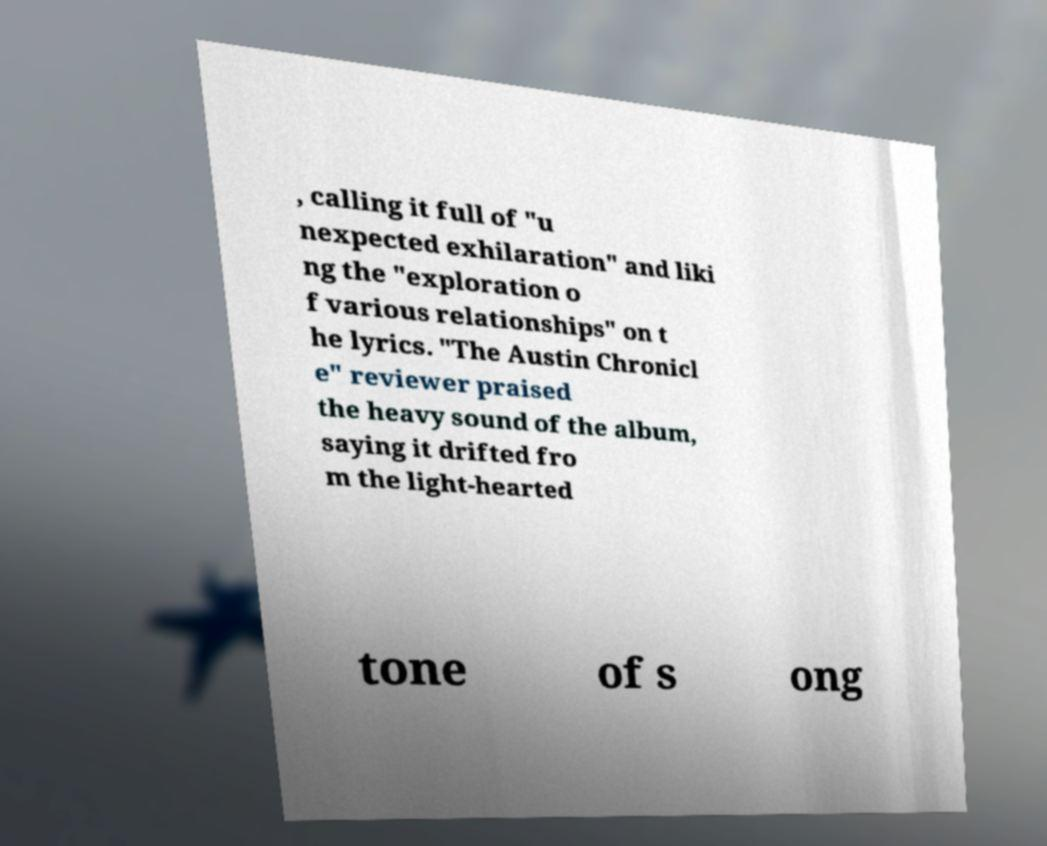Can you read and provide the text displayed in the image?This photo seems to have some interesting text. Can you extract and type it out for me? , calling it full of "u nexpected exhilaration" and liki ng the "exploration o f various relationships" on t he lyrics. "The Austin Chronicl e" reviewer praised the heavy sound of the album, saying it drifted fro m the light-hearted tone of s ong 